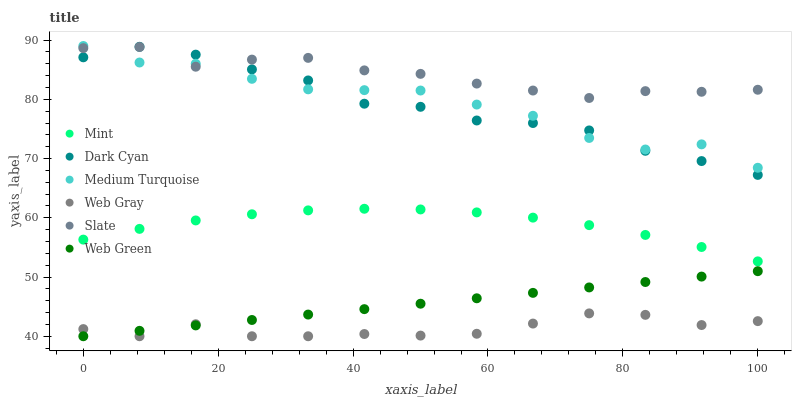Does Web Gray have the minimum area under the curve?
Answer yes or no. Yes. Does Slate have the maximum area under the curve?
Answer yes or no. Yes. Does Web Green have the minimum area under the curve?
Answer yes or no. No. Does Web Green have the maximum area under the curve?
Answer yes or no. No. Is Web Green the smoothest?
Answer yes or no. Yes. Is Medium Turquoise the roughest?
Answer yes or no. Yes. Is Slate the smoothest?
Answer yes or no. No. Is Slate the roughest?
Answer yes or no. No. Does Web Gray have the lowest value?
Answer yes or no. Yes. Does Slate have the lowest value?
Answer yes or no. No. Does Medium Turquoise have the highest value?
Answer yes or no. Yes. Does Slate have the highest value?
Answer yes or no. No. Is Web Green less than Slate?
Answer yes or no. Yes. Is Medium Turquoise greater than Web Green?
Answer yes or no. Yes. Does Web Gray intersect Web Green?
Answer yes or no. Yes. Is Web Gray less than Web Green?
Answer yes or no. No. Is Web Gray greater than Web Green?
Answer yes or no. No. Does Web Green intersect Slate?
Answer yes or no. No. 